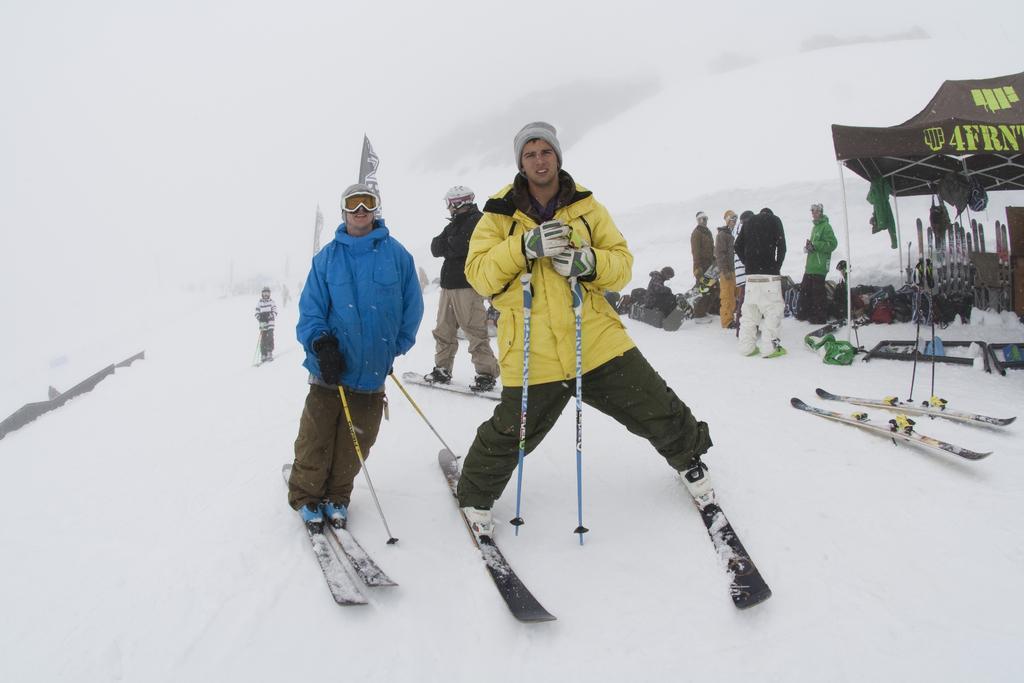Describe this image in one or two sentences. In this image we can see a few people, some of them are standing on the skis, there is a tent, skis, bags, flags, also we can see the snow. 